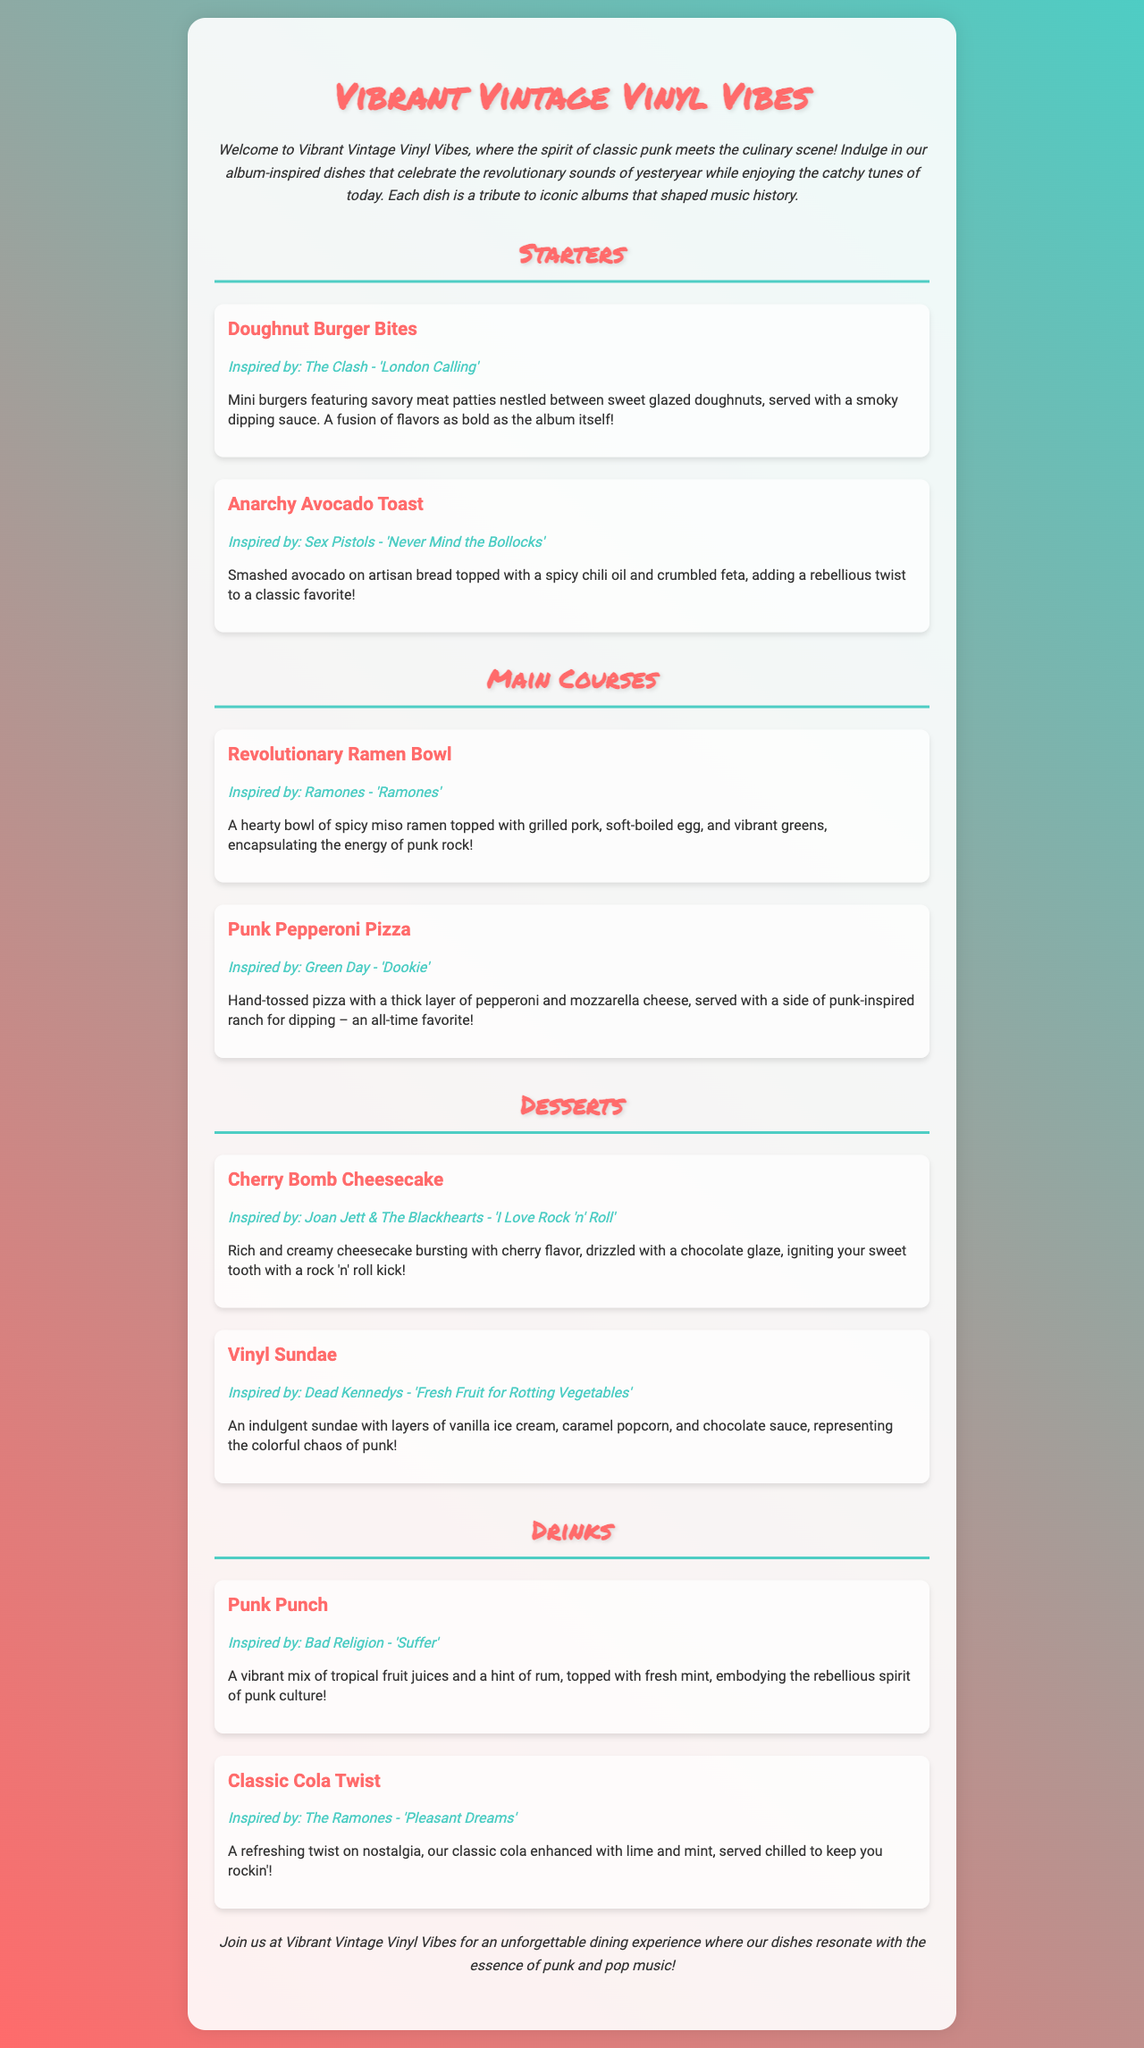what is the name of the restaurant? The name of the restaurant is prominently displayed at the top of the menu document.
Answer: Vibrant Vintage Vinyl Vibes which dish is inspired by The Clash? The menu lists several dishes along with their inspirations; this specific one is mentioned explicitly.
Answer: Doughnut Burger Bites how many main courses are listed? By counting the main courses specifically stated in the menu section, the number can be determined.
Answer: 2 what type of drink is the Punk Punch? The description gives insight into what kind of drink it is and its characteristics.
Answer: A vibrant mix of tropical fruit juices and a hint of rum which dessert features chocolate glaze? This dessert is highlighted within the dessert section of the menu that mentions a specific topping.
Answer: Cherry Bomb Cheesecake what is the main ingredient in the Anarchy Avocado Toast? The name and description of the dish indicate the key ingredient used in it.
Answer: Avocado which album inspired the Vinyl Sundae? The connection between the dessert and its musical inspiration is clearly stated in the description.
Answer: Dead Kennedys - 'Fresh Fruit for Rotting Vegetables' what genre of music is the theme of the menu? The introduction and other sections of the document emphasize the specific music genre being celebrated.
Answer: Punk 